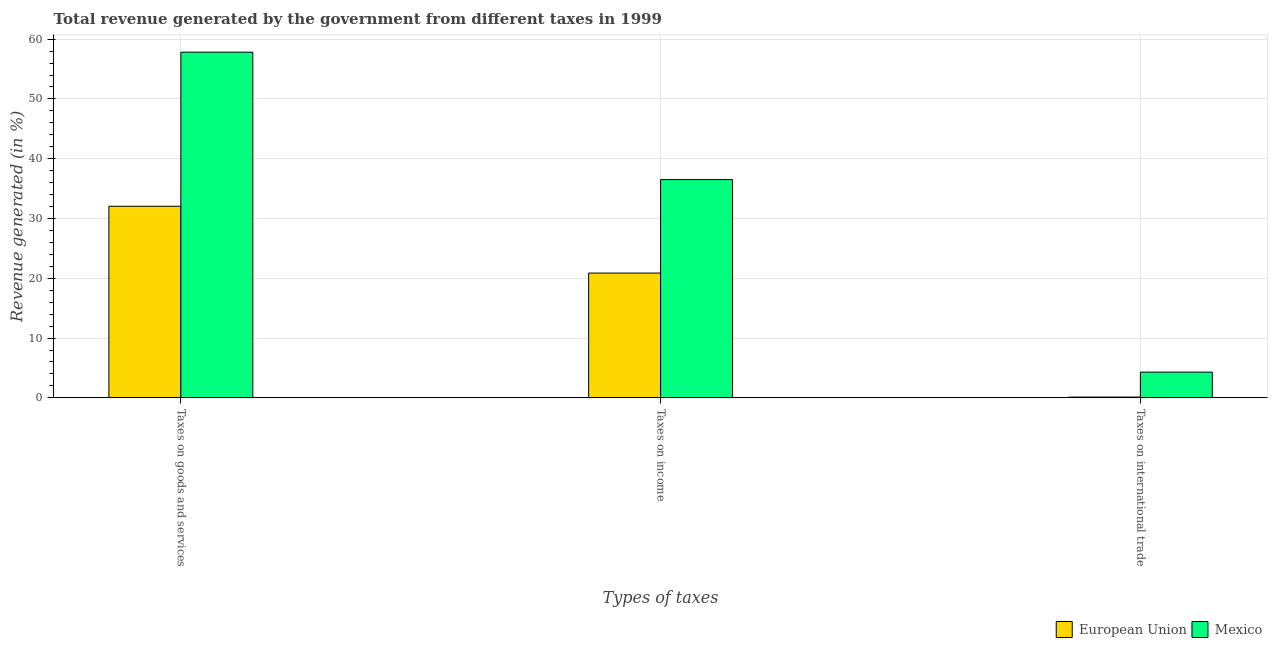How many different coloured bars are there?
Your response must be concise. 2. Are the number of bars per tick equal to the number of legend labels?
Provide a succinct answer. Yes. How many bars are there on the 3rd tick from the right?
Make the answer very short. 2. What is the label of the 1st group of bars from the left?
Offer a terse response. Taxes on goods and services. What is the percentage of revenue generated by taxes on income in Mexico?
Make the answer very short. 36.51. Across all countries, what is the maximum percentage of revenue generated by tax on international trade?
Ensure brevity in your answer.  4.31. Across all countries, what is the minimum percentage of revenue generated by taxes on income?
Your answer should be very brief. 20.87. What is the total percentage of revenue generated by taxes on income in the graph?
Provide a succinct answer. 57.38. What is the difference between the percentage of revenue generated by tax on international trade in Mexico and that in European Union?
Keep it short and to the point. 4.17. What is the difference between the percentage of revenue generated by taxes on income in European Union and the percentage of revenue generated by tax on international trade in Mexico?
Keep it short and to the point. 16.57. What is the average percentage of revenue generated by tax on international trade per country?
Offer a terse response. 2.22. What is the difference between the percentage of revenue generated by taxes on goods and services and percentage of revenue generated by tax on international trade in Mexico?
Your answer should be compact. 53.51. In how many countries, is the percentage of revenue generated by tax on international trade greater than 40 %?
Provide a succinct answer. 0. What is the ratio of the percentage of revenue generated by taxes on income in Mexico to that in European Union?
Offer a terse response. 1.75. Is the difference between the percentage of revenue generated by tax on international trade in Mexico and European Union greater than the difference between the percentage of revenue generated by taxes on income in Mexico and European Union?
Your response must be concise. No. What is the difference between the highest and the second highest percentage of revenue generated by taxes on income?
Offer a terse response. 15.64. What is the difference between the highest and the lowest percentage of revenue generated by tax on international trade?
Your answer should be compact. 4.17. In how many countries, is the percentage of revenue generated by tax on international trade greater than the average percentage of revenue generated by tax on international trade taken over all countries?
Offer a terse response. 1. Is the sum of the percentage of revenue generated by tax on international trade in European Union and Mexico greater than the maximum percentage of revenue generated by taxes on income across all countries?
Make the answer very short. No. What does the 1st bar from the left in Taxes on international trade represents?
Your answer should be compact. European Union. What does the 1st bar from the right in Taxes on income represents?
Give a very brief answer. Mexico. Is it the case that in every country, the sum of the percentage of revenue generated by taxes on goods and services and percentage of revenue generated by taxes on income is greater than the percentage of revenue generated by tax on international trade?
Your response must be concise. Yes. How many countries are there in the graph?
Give a very brief answer. 2. Are the values on the major ticks of Y-axis written in scientific E-notation?
Ensure brevity in your answer.  No. Does the graph contain any zero values?
Make the answer very short. No. How many legend labels are there?
Provide a succinct answer. 2. How are the legend labels stacked?
Offer a terse response. Horizontal. What is the title of the graph?
Your answer should be very brief. Total revenue generated by the government from different taxes in 1999. What is the label or title of the X-axis?
Ensure brevity in your answer.  Types of taxes. What is the label or title of the Y-axis?
Provide a short and direct response. Revenue generated (in %). What is the Revenue generated (in %) in European Union in Taxes on goods and services?
Give a very brief answer. 32.05. What is the Revenue generated (in %) of Mexico in Taxes on goods and services?
Provide a short and direct response. 57.82. What is the Revenue generated (in %) of European Union in Taxes on income?
Your answer should be compact. 20.87. What is the Revenue generated (in %) in Mexico in Taxes on income?
Keep it short and to the point. 36.51. What is the Revenue generated (in %) of European Union in Taxes on international trade?
Provide a succinct answer. 0.13. What is the Revenue generated (in %) in Mexico in Taxes on international trade?
Your answer should be compact. 4.31. Across all Types of taxes, what is the maximum Revenue generated (in %) in European Union?
Keep it short and to the point. 32.05. Across all Types of taxes, what is the maximum Revenue generated (in %) of Mexico?
Provide a succinct answer. 57.82. Across all Types of taxes, what is the minimum Revenue generated (in %) of European Union?
Ensure brevity in your answer.  0.13. Across all Types of taxes, what is the minimum Revenue generated (in %) in Mexico?
Ensure brevity in your answer.  4.31. What is the total Revenue generated (in %) in European Union in the graph?
Make the answer very short. 53.06. What is the total Revenue generated (in %) in Mexico in the graph?
Your response must be concise. 98.64. What is the difference between the Revenue generated (in %) in European Union in Taxes on goods and services and that in Taxes on income?
Offer a terse response. 11.18. What is the difference between the Revenue generated (in %) of Mexico in Taxes on goods and services and that in Taxes on income?
Give a very brief answer. 21.31. What is the difference between the Revenue generated (in %) of European Union in Taxes on goods and services and that in Taxes on international trade?
Your answer should be compact. 31.92. What is the difference between the Revenue generated (in %) of Mexico in Taxes on goods and services and that in Taxes on international trade?
Offer a terse response. 53.51. What is the difference between the Revenue generated (in %) of European Union in Taxes on income and that in Taxes on international trade?
Ensure brevity in your answer.  20.74. What is the difference between the Revenue generated (in %) in Mexico in Taxes on income and that in Taxes on international trade?
Your answer should be very brief. 32.2. What is the difference between the Revenue generated (in %) in European Union in Taxes on goods and services and the Revenue generated (in %) in Mexico in Taxes on income?
Keep it short and to the point. -4.46. What is the difference between the Revenue generated (in %) in European Union in Taxes on goods and services and the Revenue generated (in %) in Mexico in Taxes on international trade?
Your answer should be compact. 27.74. What is the difference between the Revenue generated (in %) of European Union in Taxes on income and the Revenue generated (in %) of Mexico in Taxes on international trade?
Offer a terse response. 16.57. What is the average Revenue generated (in %) in European Union per Types of taxes?
Your answer should be compact. 17.69. What is the average Revenue generated (in %) in Mexico per Types of taxes?
Give a very brief answer. 32.88. What is the difference between the Revenue generated (in %) of European Union and Revenue generated (in %) of Mexico in Taxes on goods and services?
Your answer should be very brief. -25.77. What is the difference between the Revenue generated (in %) in European Union and Revenue generated (in %) in Mexico in Taxes on income?
Provide a succinct answer. -15.64. What is the difference between the Revenue generated (in %) in European Union and Revenue generated (in %) in Mexico in Taxes on international trade?
Offer a terse response. -4.17. What is the ratio of the Revenue generated (in %) of European Union in Taxes on goods and services to that in Taxes on income?
Your answer should be very brief. 1.54. What is the ratio of the Revenue generated (in %) in Mexico in Taxes on goods and services to that in Taxes on income?
Provide a succinct answer. 1.58. What is the ratio of the Revenue generated (in %) in European Union in Taxes on goods and services to that in Taxes on international trade?
Your answer should be compact. 238.82. What is the ratio of the Revenue generated (in %) of Mexico in Taxes on goods and services to that in Taxes on international trade?
Offer a terse response. 13.43. What is the ratio of the Revenue generated (in %) of European Union in Taxes on income to that in Taxes on international trade?
Keep it short and to the point. 155.54. What is the ratio of the Revenue generated (in %) in Mexico in Taxes on income to that in Taxes on international trade?
Your answer should be compact. 8.48. What is the difference between the highest and the second highest Revenue generated (in %) of European Union?
Your answer should be very brief. 11.18. What is the difference between the highest and the second highest Revenue generated (in %) of Mexico?
Make the answer very short. 21.31. What is the difference between the highest and the lowest Revenue generated (in %) in European Union?
Your answer should be very brief. 31.92. What is the difference between the highest and the lowest Revenue generated (in %) in Mexico?
Make the answer very short. 53.51. 